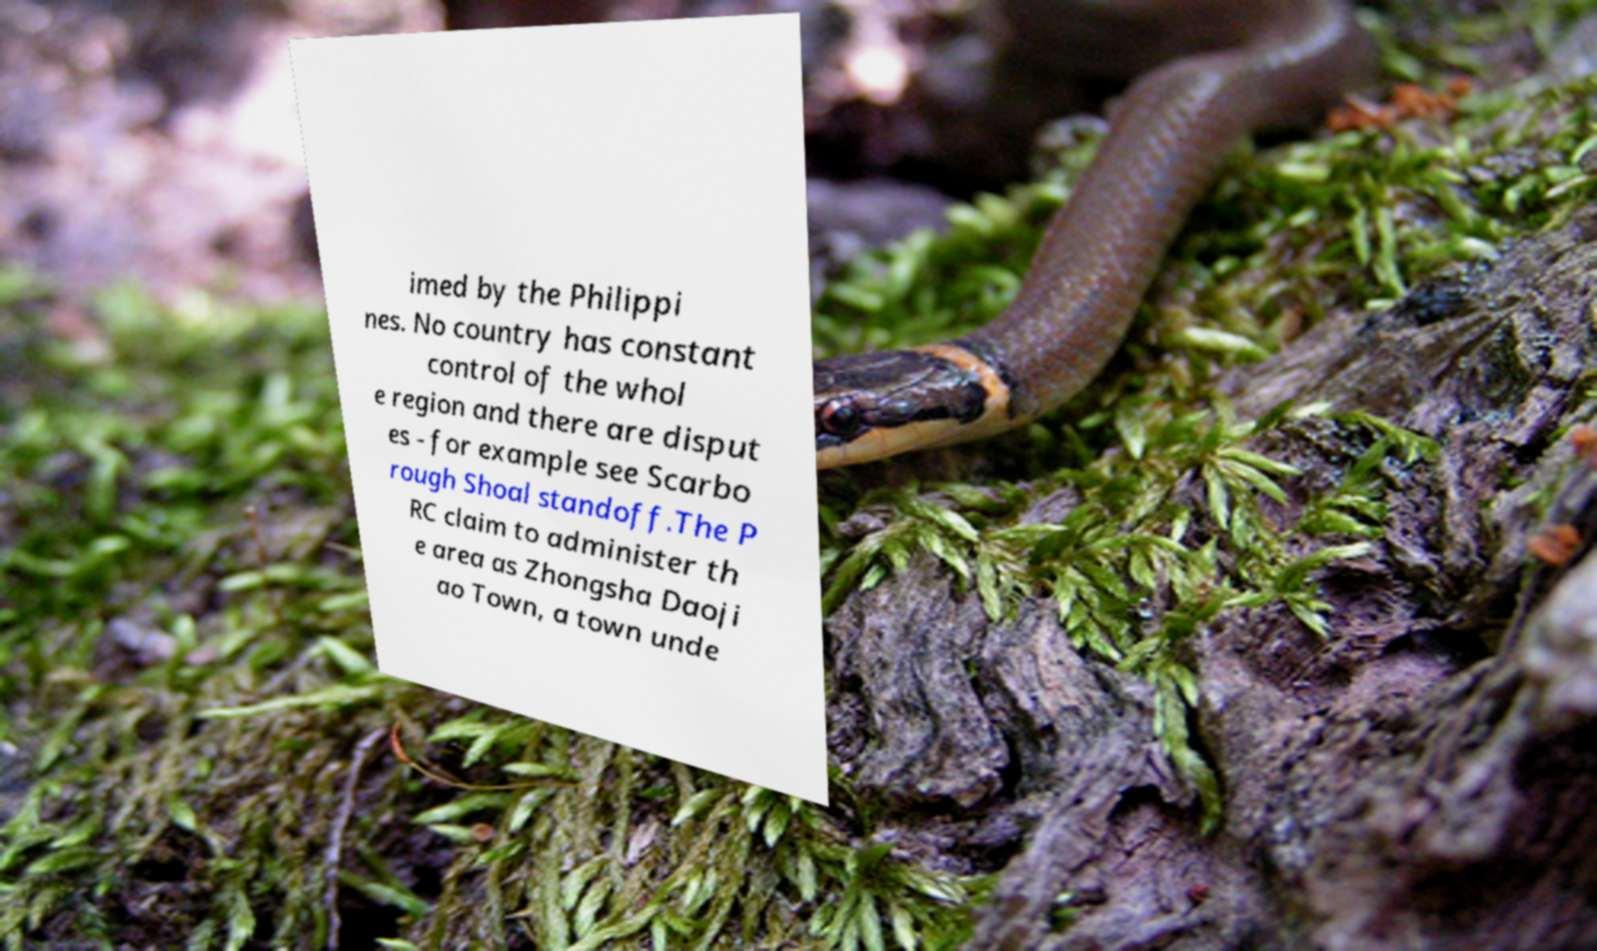I need the written content from this picture converted into text. Can you do that? imed by the Philippi nes. No country has constant control of the whol e region and there are disput es - for example see Scarbo rough Shoal standoff.The P RC claim to administer th e area as Zhongsha Daoji ao Town, a town unde 